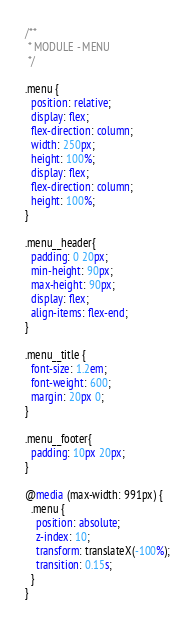<code> <loc_0><loc_0><loc_500><loc_500><_CSS_>/**
 * MODULE - MENU
 */

.menu {
  position: relative;
  display: flex;
  flex-direction: column;
  width: 250px;
  height: 100%;
  display: flex;
  flex-direction: column;
  height: 100%;
}

.menu__header{
  padding: 0 20px;
  min-height: 90px;
  max-height: 90px;
  display: flex;
  align-items: flex-end;
}

.menu__title {
  font-size: 1.2em;
  font-weight: 600;
  margin: 20px 0;
}

.menu__footer{
  padding: 10px 20px;
}

@media (max-width: 991px) {
  .menu {
    position: absolute;
    z-index: 10;
    transform: translateX(-100%);
    transition: 0.15s;
  }
}</code> 